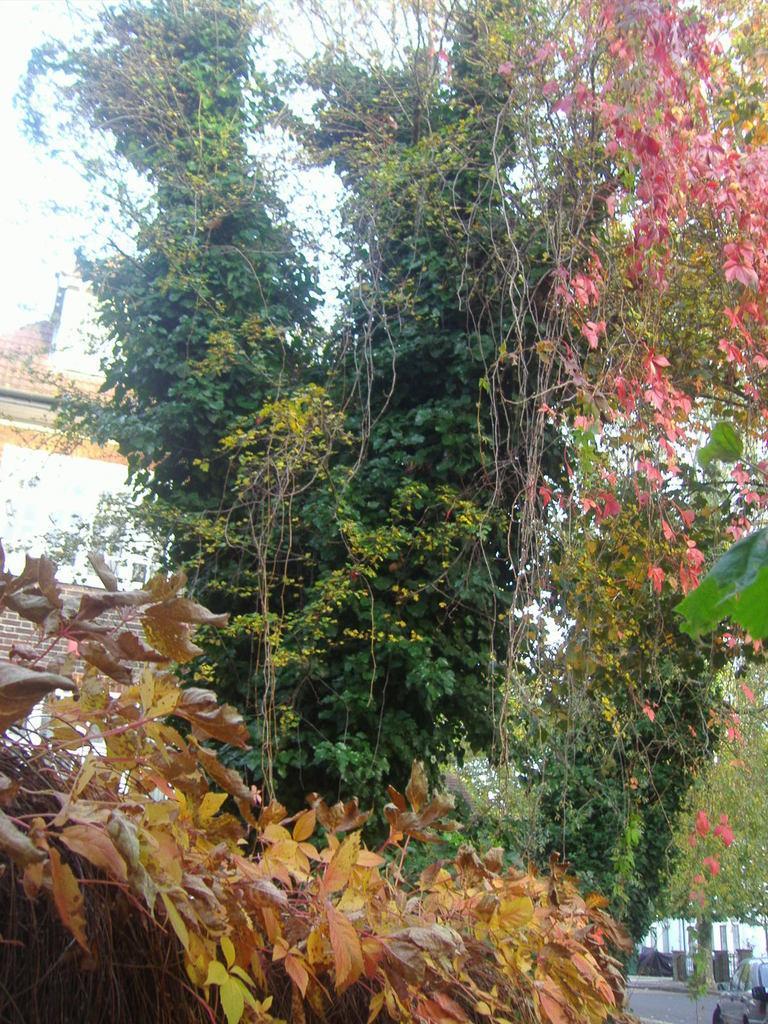Can you describe this image briefly? This picture is clicked outside. In the foreground we can see the dry leaves and the trees. In the background there is a sky, building and a vehicle and some other objects. 